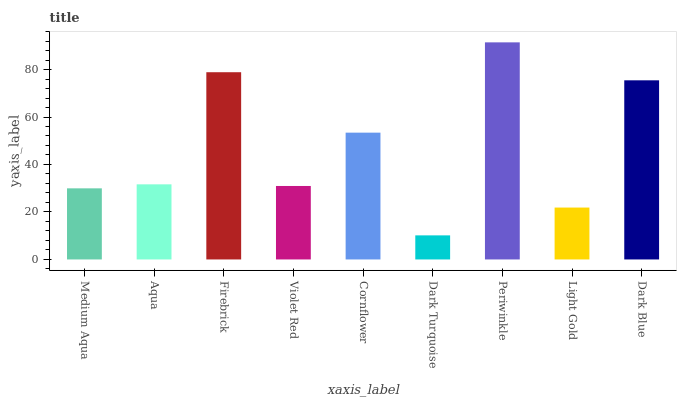Is Dark Turquoise the minimum?
Answer yes or no. Yes. Is Periwinkle the maximum?
Answer yes or no. Yes. Is Aqua the minimum?
Answer yes or no. No. Is Aqua the maximum?
Answer yes or no. No. Is Aqua greater than Medium Aqua?
Answer yes or no. Yes. Is Medium Aqua less than Aqua?
Answer yes or no. Yes. Is Medium Aqua greater than Aqua?
Answer yes or no. No. Is Aqua less than Medium Aqua?
Answer yes or no. No. Is Aqua the high median?
Answer yes or no. Yes. Is Aqua the low median?
Answer yes or no. Yes. Is Firebrick the high median?
Answer yes or no. No. Is Cornflower the low median?
Answer yes or no. No. 